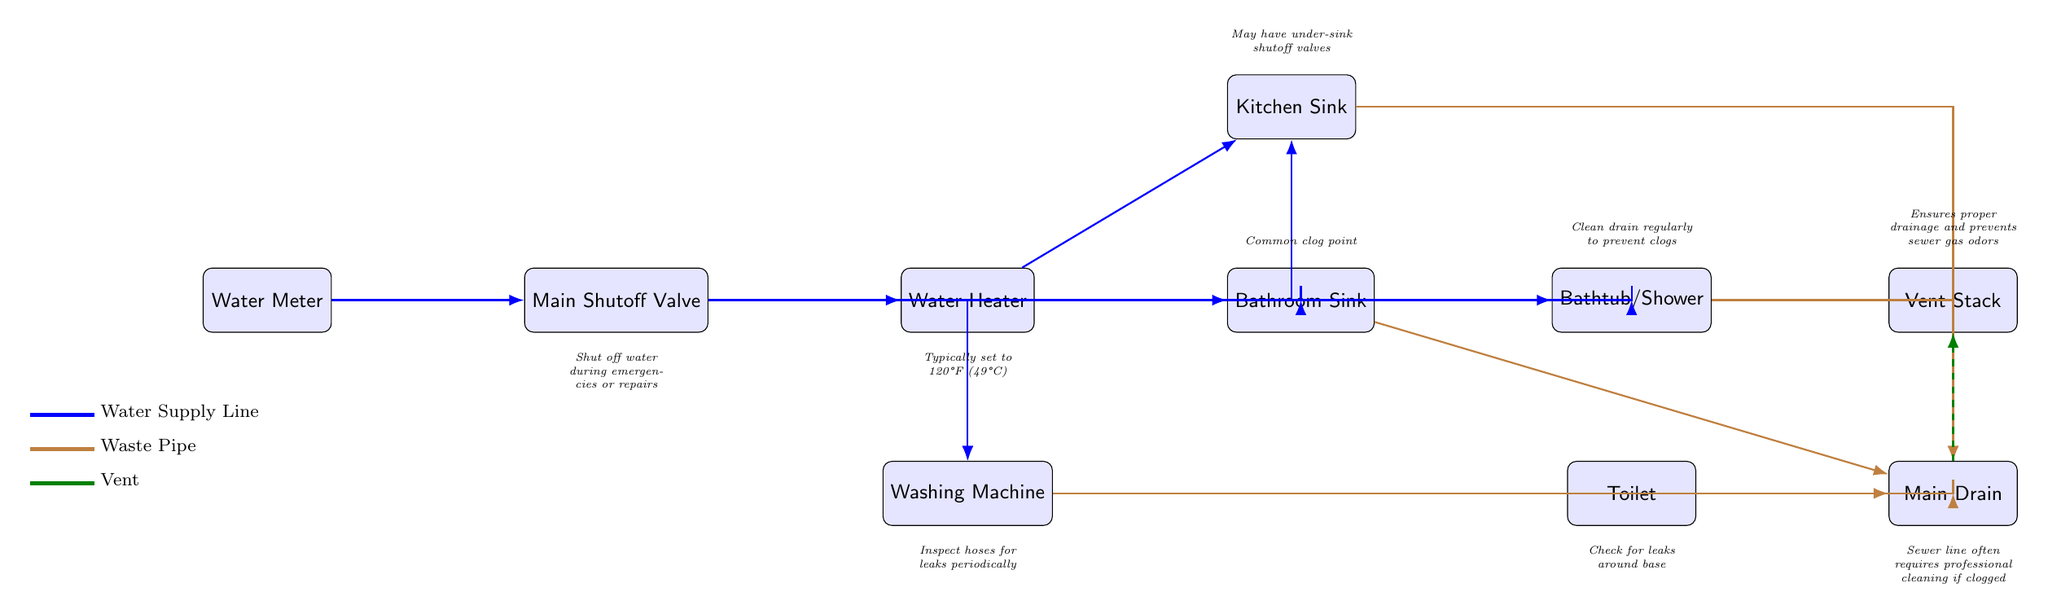What is the first node in the plumbing system? The first node, representing the entry point of water into the plumbing system, is the "Water Meter." It is positioned at the far left of the diagram.
Answer: Water Meter What color represents the waste pipe in the diagram? The waste pipe is represented by the color brown in the diagram. You can see this color used at several key points, including where the kitchen sink and bathroom sink drain into the main drain.
Answer: Brown How many supply lines are shown in the diagram? The diagram illustrates five supply lines leading from the main shutoff valve to the various appliances and sinks. Each line pathways towards the water heater, kitchen sink, bathroom sink, bathtub/shower, and washing machine.
Answer: Five Which node indicates where to check for leaks around the base? The node that emphasizes checking for leaks around the base is the "Toilet." It is arranged below the bathroom sink in the diagram and is annotated with this specific recommendation.
Answer: Toilet What typically should the water heater be set to in degrees Fahrenheit? The annotation below the water heater suggests that it should typically be set to 120°F. This value is critical for optimal water temperature and safety.
Answer: 120°F What does the vent stack ensure in the plumbing system? The vent stack is annotated with the role of ensuring proper drainage and preventing sewer gas odors. It is connected to the main drain in the diagram and facilitates airflow to maintain system balance.
Answer: Proper drainage and prevents sewer gas odors Where should one look for under-sink shutoff valves? The diagram indicates that under-sink shutoff valves are typically found at the "Kitchen Sink." This is noted as an annotation just above the kitchen sink node in the layout.
Answer: Kitchen Sink What common issue is highlighted at the bathroom sink? The common issue associated with the bathroom sink is that it is a "Common clog point." This information is provided in an annotation above the bathroom sink node, indicating a frequent maintenance concern.
Answer: Common clog point What does the annotation below the main drain advise? The annotation below the main drain suggests that the sewer line often requires professional cleaning if clogged. This highlights the potential complexity of addressing issues in that part of the plumbing system.
Answer: Professional cleaning if clogged 